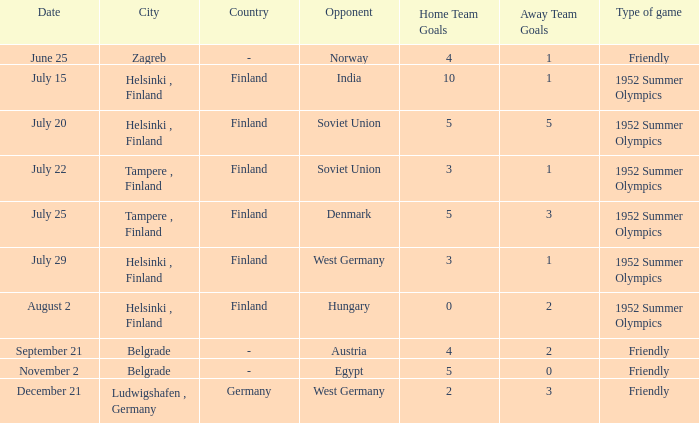With the Type is game of friendly and the City Belgrade and November 2 as the Date what were the Results¹? 5:0. 